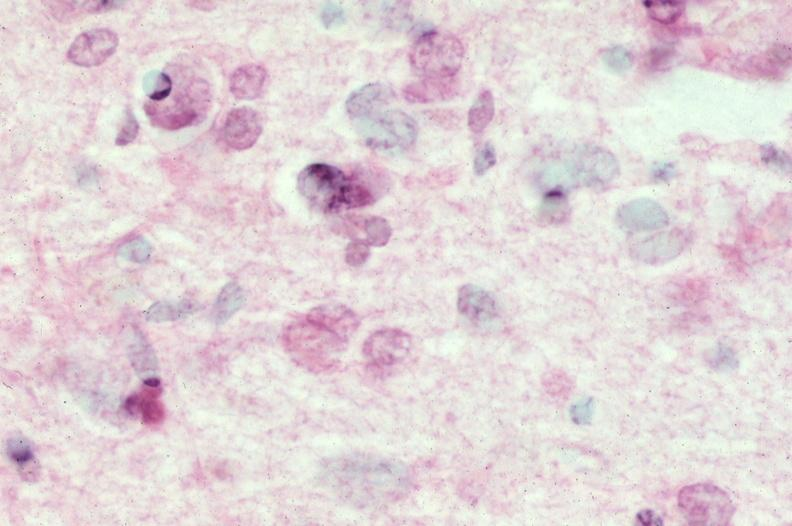what does this image show?
Answer the question using a single word or phrase. Brain 